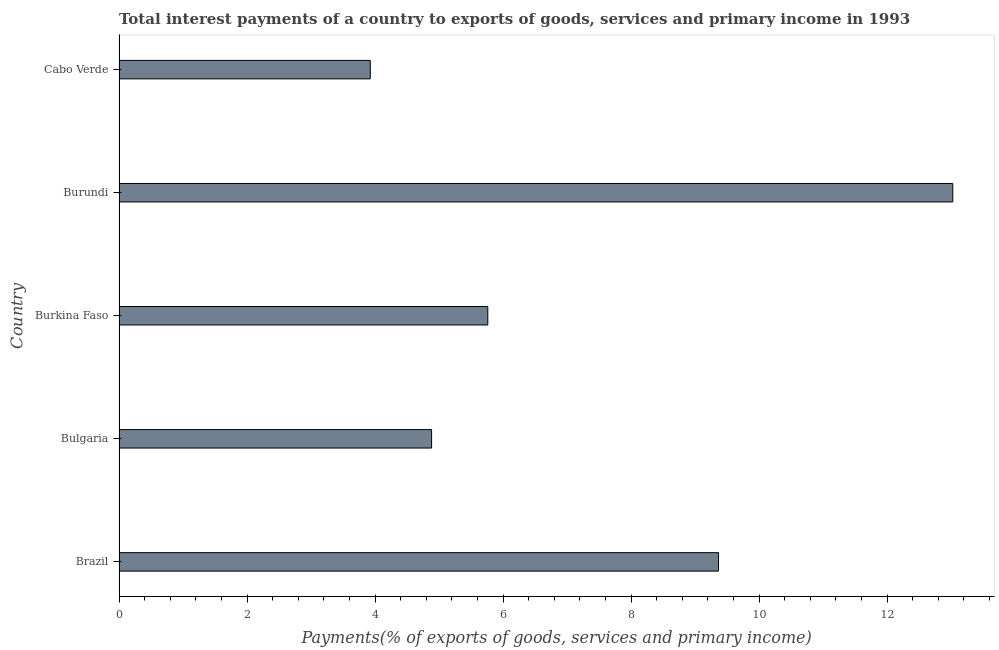Does the graph contain any zero values?
Your response must be concise. No. What is the title of the graph?
Provide a short and direct response. Total interest payments of a country to exports of goods, services and primary income in 1993. What is the label or title of the X-axis?
Offer a terse response. Payments(% of exports of goods, services and primary income). What is the label or title of the Y-axis?
Provide a succinct answer. Country. What is the total interest payments on external debt in Cabo Verde?
Your answer should be compact. 3.93. Across all countries, what is the maximum total interest payments on external debt?
Your answer should be compact. 13.03. Across all countries, what is the minimum total interest payments on external debt?
Provide a succinct answer. 3.93. In which country was the total interest payments on external debt maximum?
Your answer should be very brief. Burundi. In which country was the total interest payments on external debt minimum?
Give a very brief answer. Cabo Verde. What is the sum of the total interest payments on external debt?
Offer a very short reply. 36.97. What is the difference between the total interest payments on external debt in Burkina Faso and Burundi?
Keep it short and to the point. -7.27. What is the average total interest payments on external debt per country?
Ensure brevity in your answer.  7.39. What is the median total interest payments on external debt?
Keep it short and to the point. 5.76. What is the ratio of the total interest payments on external debt in Burkina Faso to that in Cabo Verde?
Your answer should be very brief. 1.47. Is the total interest payments on external debt in Brazil less than that in Burkina Faso?
Provide a short and direct response. No. What is the difference between the highest and the second highest total interest payments on external debt?
Offer a very short reply. 3.66. Is the sum of the total interest payments on external debt in Brazil and Burkina Faso greater than the maximum total interest payments on external debt across all countries?
Your response must be concise. Yes. Are all the bars in the graph horizontal?
Offer a terse response. Yes. How many countries are there in the graph?
Offer a terse response. 5. What is the difference between two consecutive major ticks on the X-axis?
Ensure brevity in your answer.  2. Are the values on the major ticks of X-axis written in scientific E-notation?
Your response must be concise. No. What is the Payments(% of exports of goods, services and primary income) in Brazil?
Keep it short and to the point. 9.37. What is the Payments(% of exports of goods, services and primary income) in Bulgaria?
Your response must be concise. 4.88. What is the Payments(% of exports of goods, services and primary income) of Burkina Faso?
Your answer should be very brief. 5.76. What is the Payments(% of exports of goods, services and primary income) in Burundi?
Your response must be concise. 13.03. What is the Payments(% of exports of goods, services and primary income) in Cabo Verde?
Offer a terse response. 3.93. What is the difference between the Payments(% of exports of goods, services and primary income) in Brazil and Bulgaria?
Make the answer very short. 4.48. What is the difference between the Payments(% of exports of goods, services and primary income) in Brazil and Burkina Faso?
Make the answer very short. 3.6. What is the difference between the Payments(% of exports of goods, services and primary income) in Brazil and Burundi?
Keep it short and to the point. -3.66. What is the difference between the Payments(% of exports of goods, services and primary income) in Brazil and Cabo Verde?
Ensure brevity in your answer.  5.44. What is the difference between the Payments(% of exports of goods, services and primary income) in Bulgaria and Burkina Faso?
Provide a succinct answer. -0.88. What is the difference between the Payments(% of exports of goods, services and primary income) in Bulgaria and Burundi?
Offer a very short reply. -8.14. What is the difference between the Payments(% of exports of goods, services and primary income) in Bulgaria and Cabo Verde?
Provide a short and direct response. 0.96. What is the difference between the Payments(% of exports of goods, services and primary income) in Burkina Faso and Burundi?
Offer a very short reply. -7.27. What is the difference between the Payments(% of exports of goods, services and primary income) in Burkina Faso and Cabo Verde?
Keep it short and to the point. 1.84. What is the difference between the Payments(% of exports of goods, services and primary income) in Burundi and Cabo Verde?
Your answer should be compact. 9.1. What is the ratio of the Payments(% of exports of goods, services and primary income) in Brazil to that in Bulgaria?
Give a very brief answer. 1.92. What is the ratio of the Payments(% of exports of goods, services and primary income) in Brazil to that in Burkina Faso?
Keep it short and to the point. 1.63. What is the ratio of the Payments(% of exports of goods, services and primary income) in Brazil to that in Burundi?
Your response must be concise. 0.72. What is the ratio of the Payments(% of exports of goods, services and primary income) in Brazil to that in Cabo Verde?
Give a very brief answer. 2.39. What is the ratio of the Payments(% of exports of goods, services and primary income) in Bulgaria to that in Burkina Faso?
Make the answer very short. 0.85. What is the ratio of the Payments(% of exports of goods, services and primary income) in Bulgaria to that in Burundi?
Your response must be concise. 0.38. What is the ratio of the Payments(% of exports of goods, services and primary income) in Bulgaria to that in Cabo Verde?
Keep it short and to the point. 1.24. What is the ratio of the Payments(% of exports of goods, services and primary income) in Burkina Faso to that in Burundi?
Make the answer very short. 0.44. What is the ratio of the Payments(% of exports of goods, services and primary income) in Burkina Faso to that in Cabo Verde?
Your answer should be very brief. 1.47. What is the ratio of the Payments(% of exports of goods, services and primary income) in Burundi to that in Cabo Verde?
Keep it short and to the point. 3.32. 